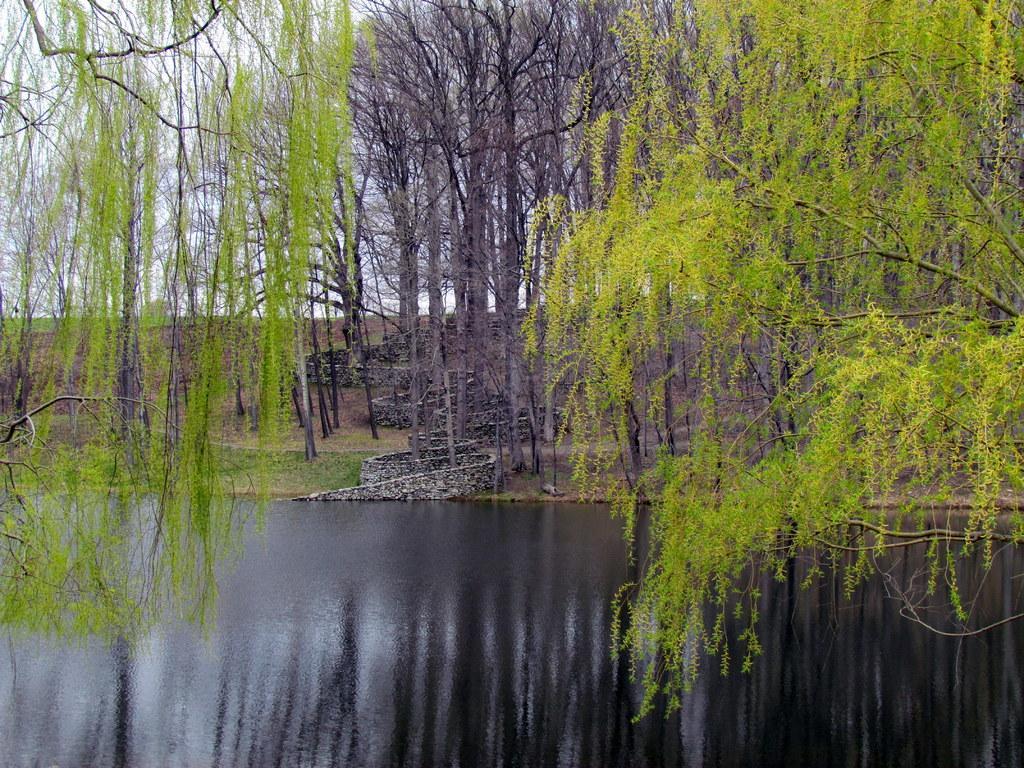How would you summarize this image in a sentence or two? In this image, we can see so many trees, grass. At the bottom, there is water. Background we can see the sky. 